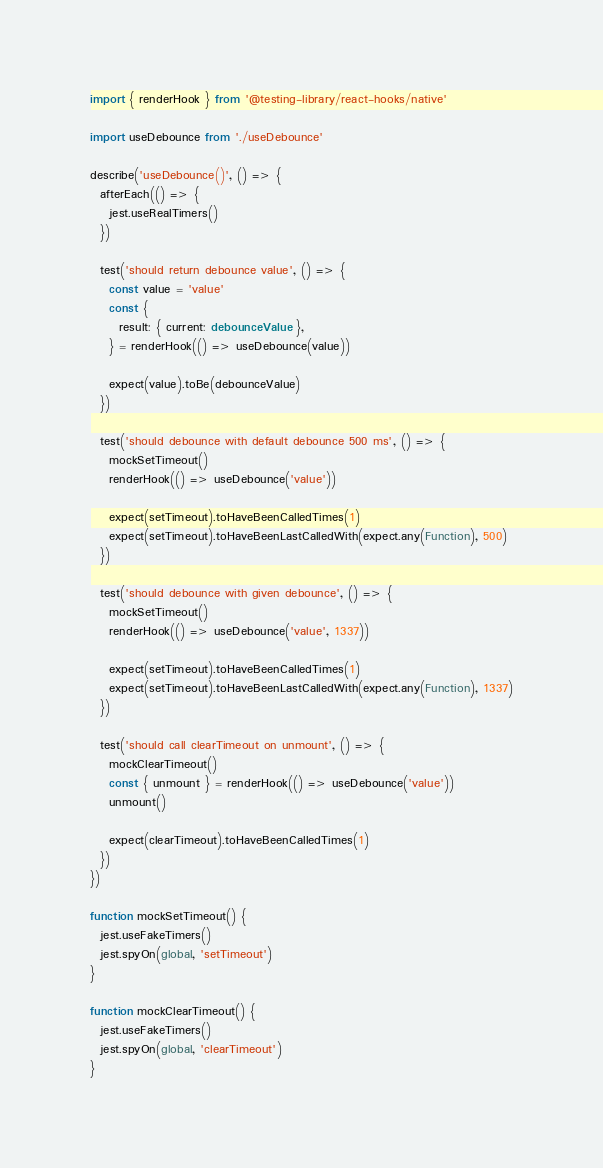Convert code to text. <code><loc_0><loc_0><loc_500><loc_500><_TypeScript_>import { renderHook } from '@testing-library/react-hooks/native'

import useDebounce from './useDebounce'

describe('useDebounce()', () => {
  afterEach(() => {
    jest.useRealTimers()
  })

  test('should return debounce value', () => {
    const value = 'value'
    const {
      result: { current: debounceValue },
    } = renderHook(() => useDebounce(value))

    expect(value).toBe(debounceValue)
  })

  test('should debounce with default debounce 500 ms', () => {
    mockSetTimeout()
    renderHook(() => useDebounce('value'))

    expect(setTimeout).toHaveBeenCalledTimes(1)
    expect(setTimeout).toHaveBeenLastCalledWith(expect.any(Function), 500)
  })

  test('should debounce with given debounce', () => {
    mockSetTimeout()
    renderHook(() => useDebounce('value', 1337))

    expect(setTimeout).toHaveBeenCalledTimes(1)
    expect(setTimeout).toHaveBeenLastCalledWith(expect.any(Function), 1337)
  })

  test('should call clearTimeout on unmount', () => {
    mockClearTimeout()
    const { unmount } = renderHook(() => useDebounce('value'))
    unmount()

    expect(clearTimeout).toHaveBeenCalledTimes(1)
  })
})

function mockSetTimeout() {
  jest.useFakeTimers()
  jest.spyOn(global, 'setTimeout')
}

function mockClearTimeout() {
  jest.useFakeTimers()
  jest.spyOn(global, 'clearTimeout')
}
</code> 